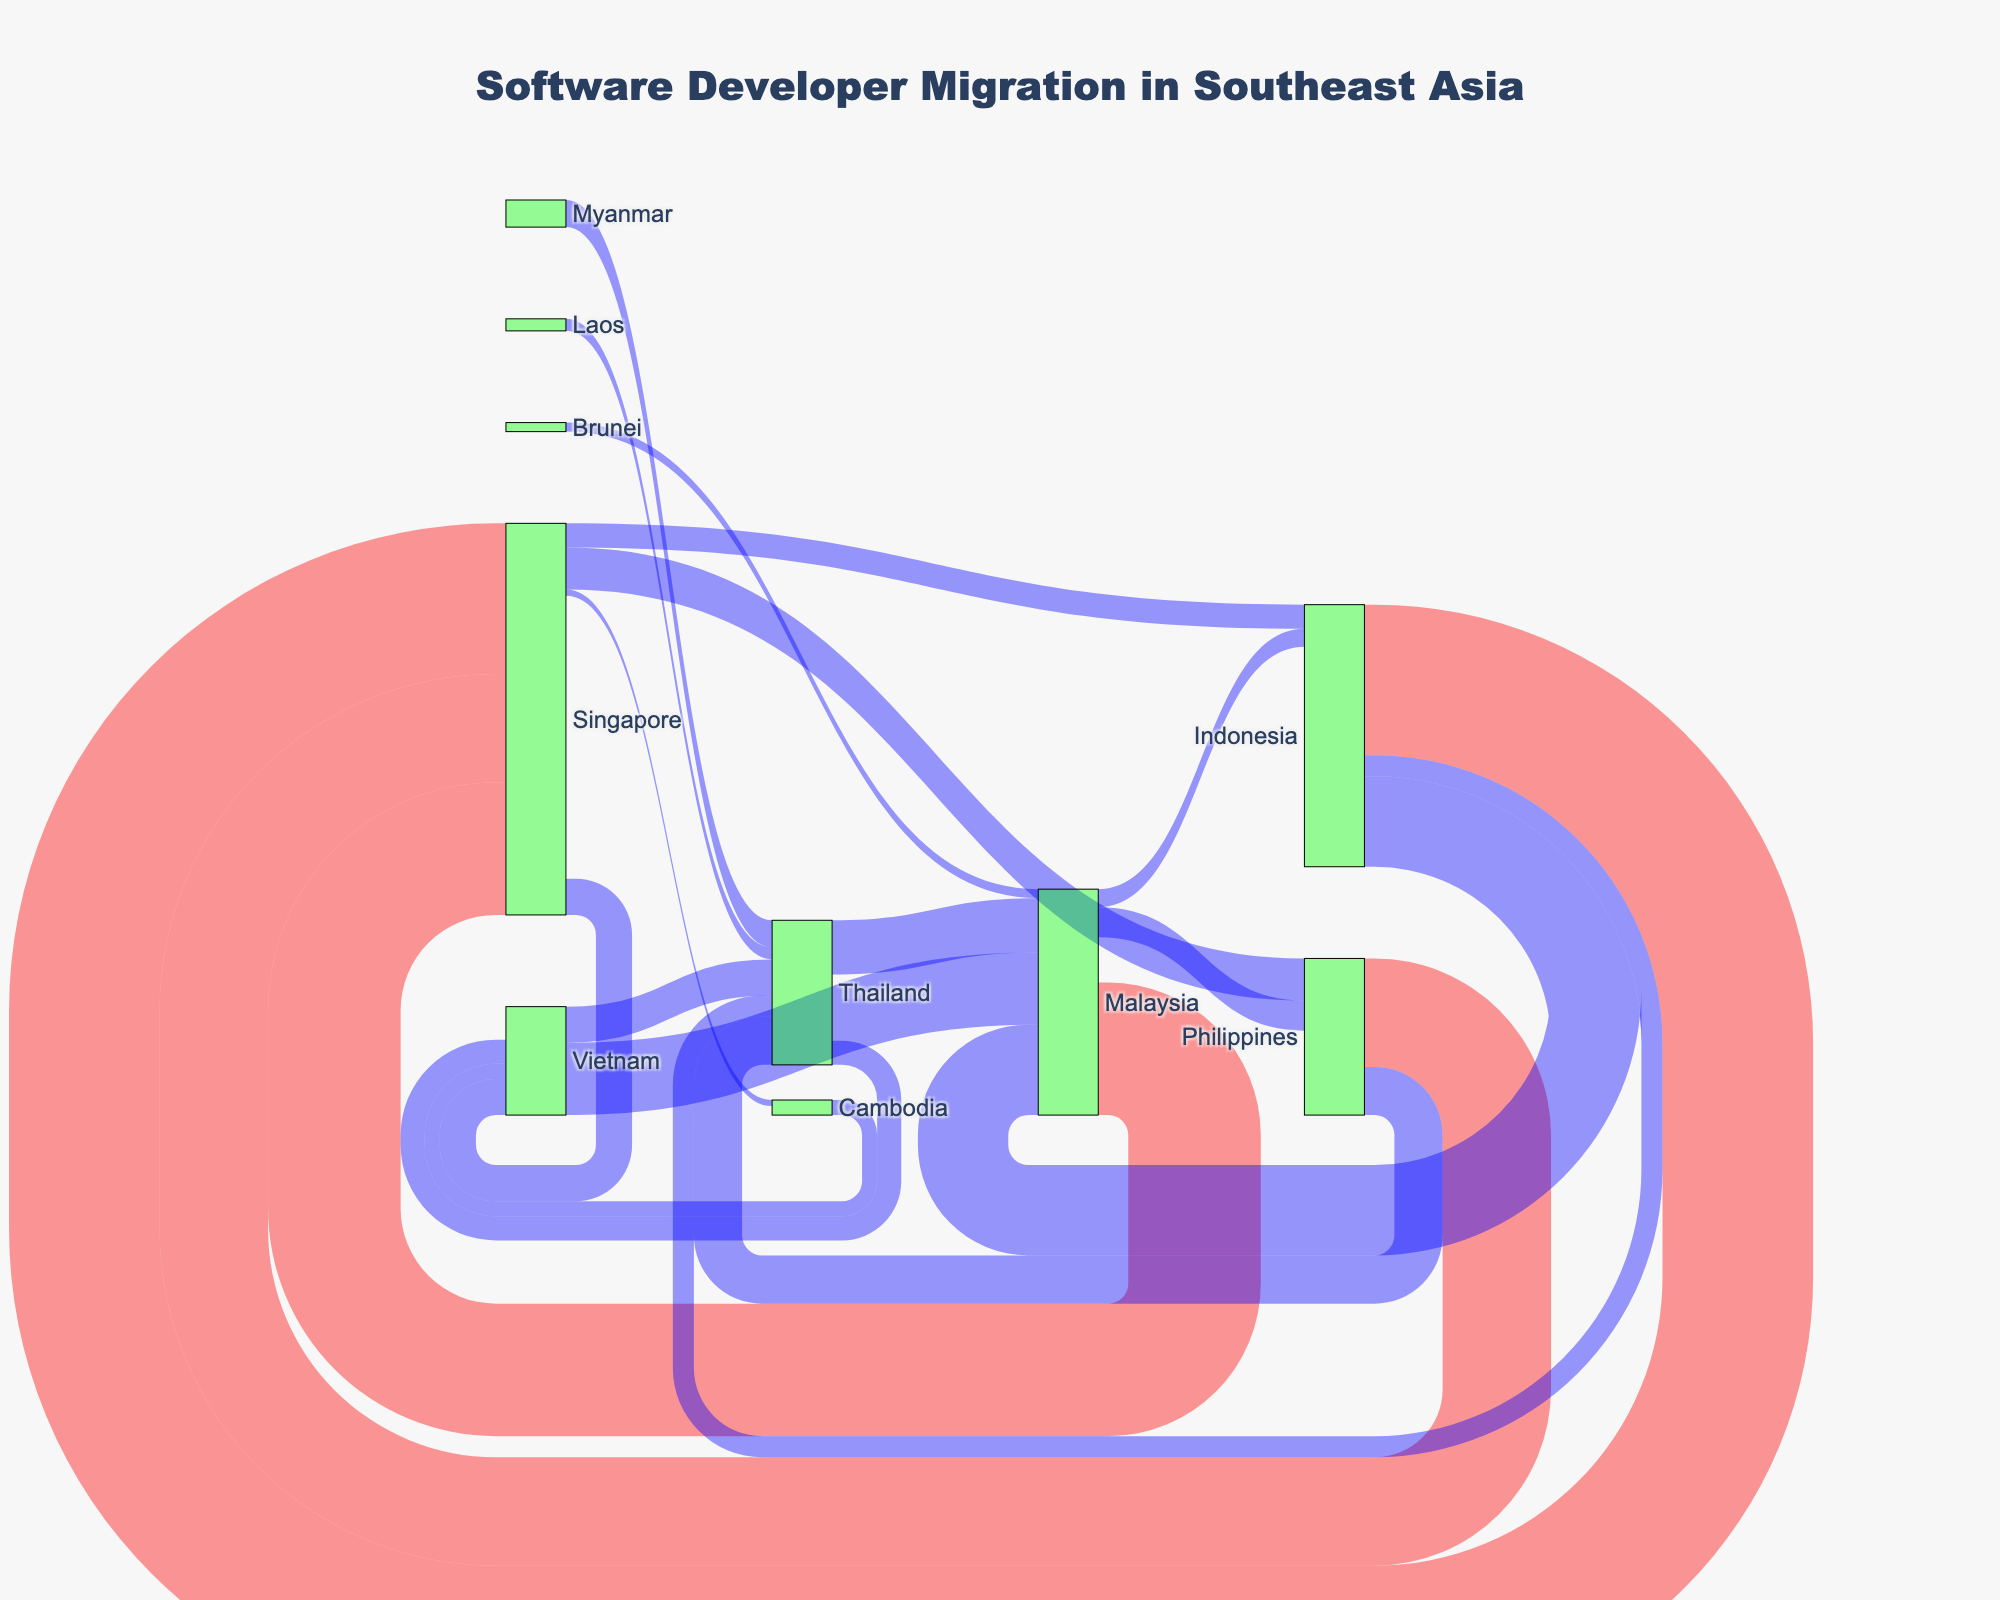What's the title of the Sankey Diagram? The title is located at the top of the figure. Reading it directly will provide the answer.
Answer: Software Developer Migration in Southeast Asia Which country receives the most software developers from Indonesia? Look at the links originating from Indonesia and check the thickness of the lines to determine the values. The thickest link indicates the country receiving the most developers.
Answer: Singapore What's the total number of developers migrating from the Philippines? Sum the values of all links originating from the Philippines (1800 to Singapore + 800 to Thailand).
Answer: 2600 Between Malaysia and Thailand, which country receives more developers from Vietnam? Compare the two links originating from Vietnam; one goes to Malaysia and the other to Thailand. The link with the higher value denotes the country receiving more developers.
Answer: Malaysia What is the color of the nodes representing source countries? Nodes representing source countries are colored based on the specified condition. By referring to the code, we see such nodes are colored in a translucent greenish shade.
Answer: Green How many developers move from Southeast Asian countries to Vietnam? Sum the values of all links that have Vietnam as the target (1200 from Malaysia + 400 from Thailand + 600 from Singapore + 250 from Cambodia).
Answer: 2450 Identify one source and one target country where the migration value is above 1500. Look for a link whose value is above 1500. Identify the corresponding source and target.
Answer: Indonesia to Singapore Which country sends the lowest number of developers to another country? Identify the link with the smallest value and note the source country of that link.
Answer: Brunei What is the combined number of developers moving into Thailand from all other countries? Sum the values of all links targeting Thailand (800 from Philippines + 600 from Vietnam + 450 from Myanmar + 200 from Laos + 350 from Indonesia).
Answer: 2400 Compare the number of developers moving from Singapore to Vietnam versus those migrating from Malaysia to the Philippines. Which is higher? Look at the links from Singapore to Vietnam and Malaysia to the Philippines, and compare their values to identify the higher one.
Answer: Singapore to Vietnam 